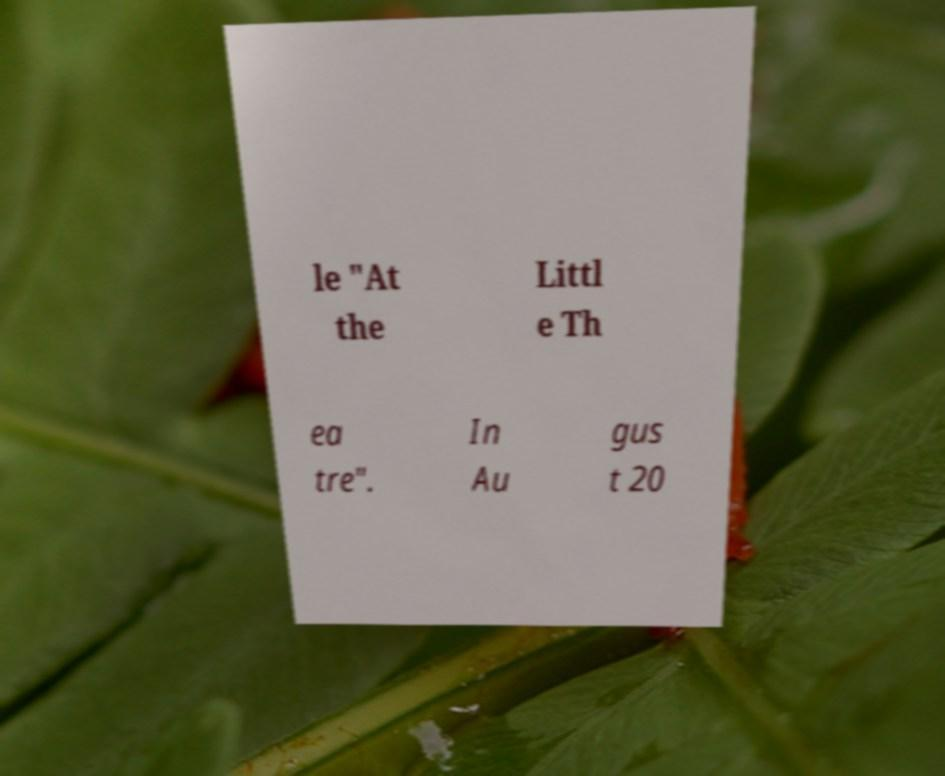I need the written content from this picture converted into text. Can you do that? le "At the Littl e Th ea tre". In Au gus t 20 